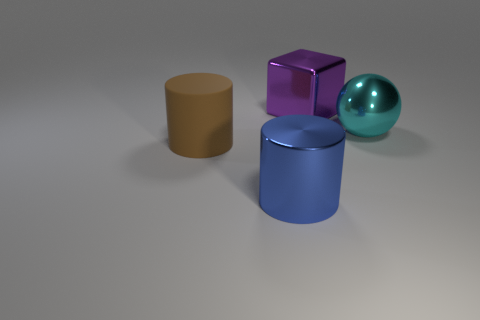Add 1 tiny yellow matte cubes. How many objects exist? 5 Subtract all cubes. How many objects are left? 3 Subtract 1 blue cylinders. How many objects are left? 3 Subtract all big blue objects. Subtract all cyan balls. How many objects are left? 2 Add 4 purple things. How many purple things are left? 5 Add 1 shiny objects. How many shiny objects exist? 4 